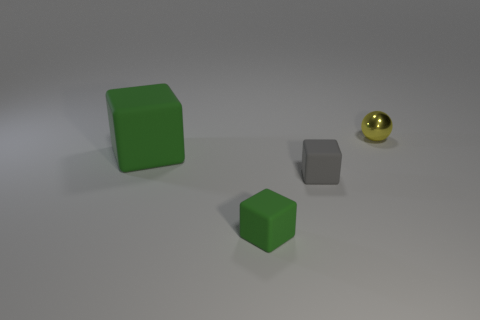Subtract all blue balls. How many green cubes are left? 2 Subtract all green matte blocks. How many blocks are left? 1 Subtract 1 cubes. How many cubes are left? 2 Subtract all purple blocks. Subtract all yellow cylinders. How many blocks are left? 3 Add 4 metal balls. How many objects exist? 8 Subtract all cubes. How many objects are left? 1 Add 4 small metallic objects. How many small metallic objects exist? 5 Subtract 0 green balls. How many objects are left? 4 Subtract all green blocks. Subtract all large green rubber things. How many objects are left? 1 Add 2 metallic things. How many metallic things are left? 3 